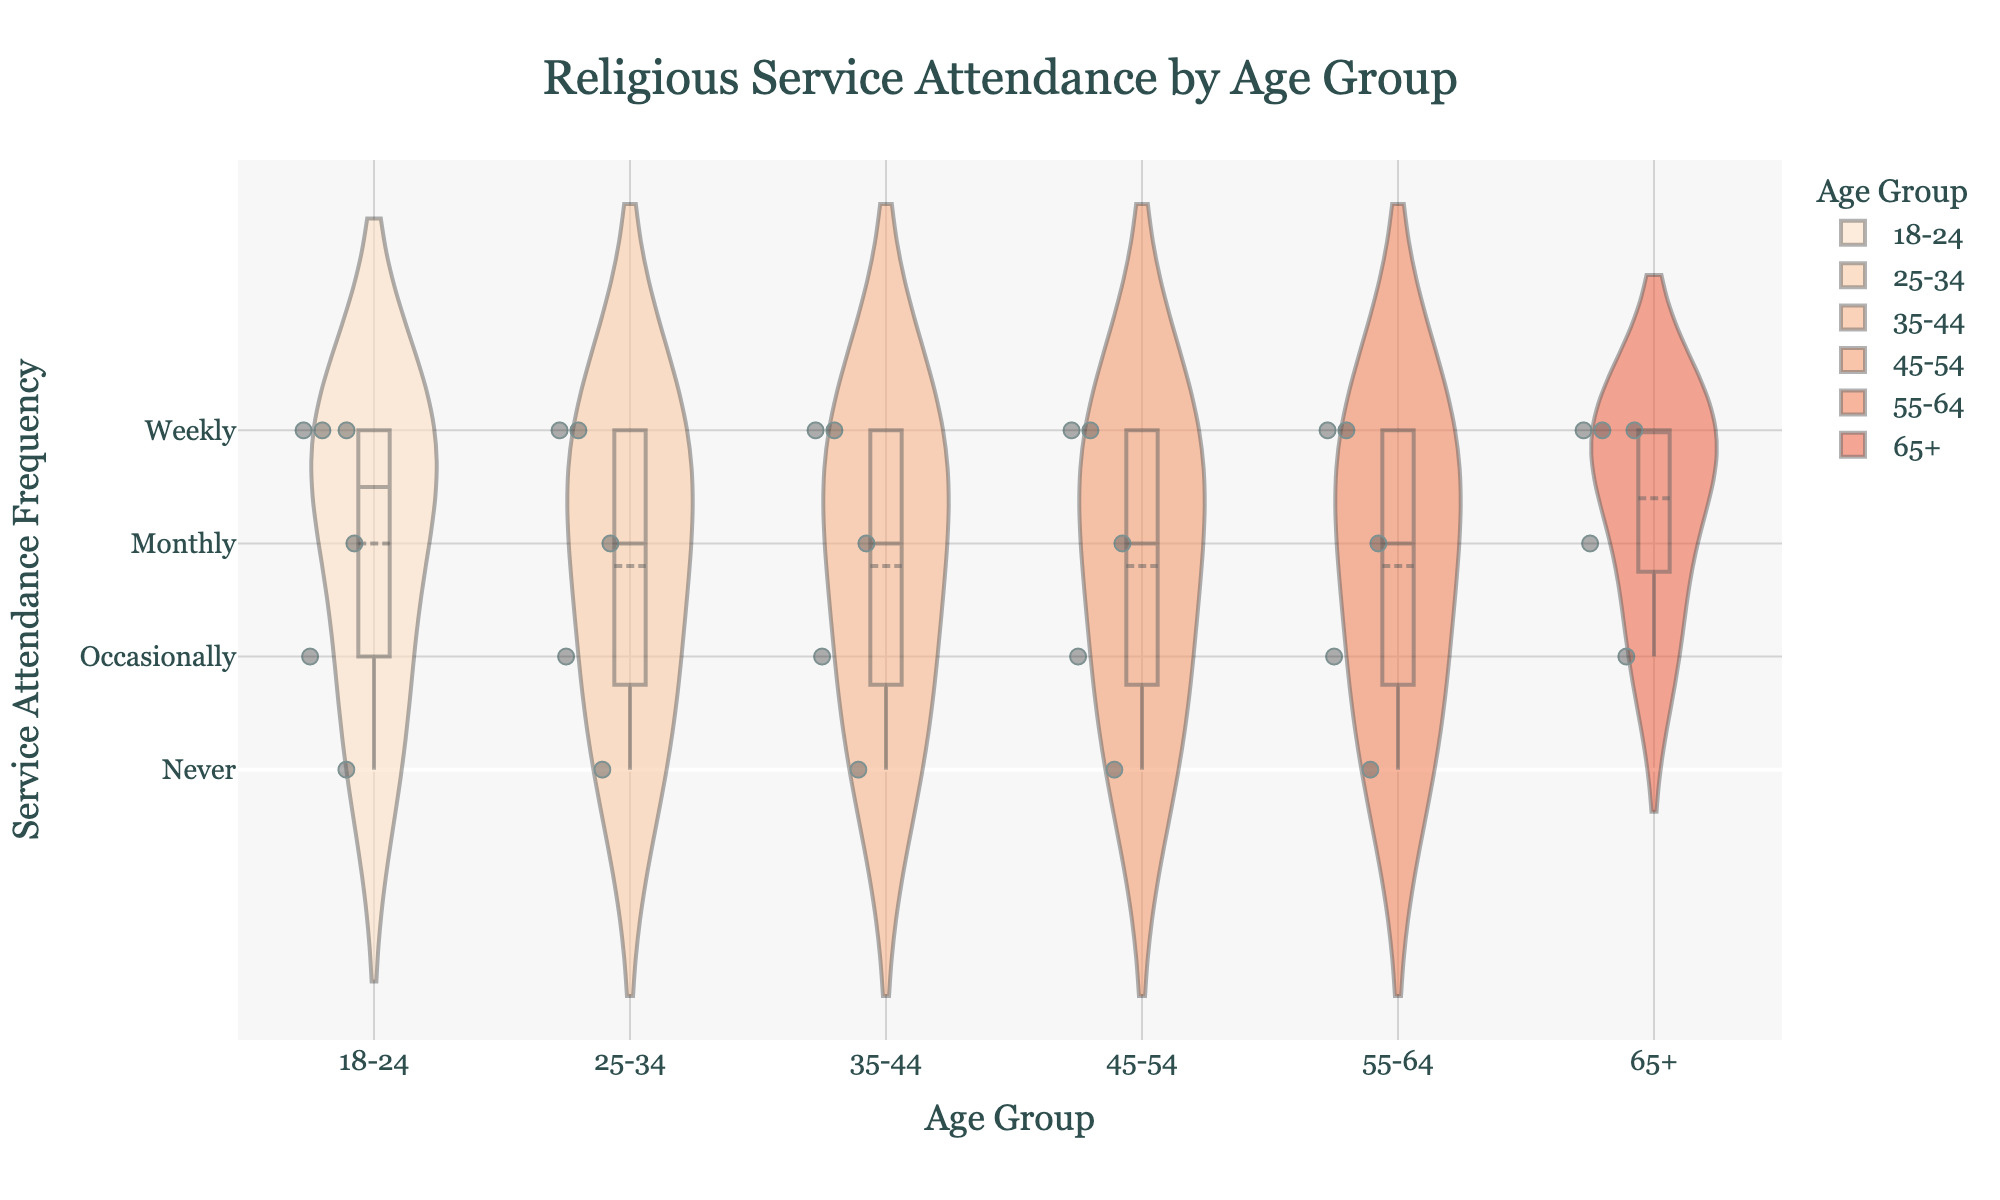what is the title of the figure? The title is located at the top center of the figure. It is usually larger and in bold. The title of this figure is "Religious Service Attendance by Age Group."
Answer: Religious Service Attendance by Age Group What age group has the most 'Weekly' attendees? Observe the peak and distribution of the 'Weekly' category for each age group. The age group with the highest density peak at 'Weekly' indicates the most attendees in that category.
Answer: 65+ How many points represent the 'Never' frequency in the 25-34 age group? 'Never' frequency is mapped to the value 0 on the y-axis. Count the jittered points at the y-value of 0 within the 25-34 age group section.
Answer: 1 Which age group shows the widest range in service attendance frequency? The range in a violin plot is from the minimum to the maximum value. Look for the age group with the longest vertical span from bottom to top.
Answer: 35-44 How does the average attendance frequency for the 18-24 age group compare to the 55-64 age group? Check the meanline positions in the violin plots for both age groups. Compare their average frequencies based on the meanline.
Answer: 55-64 has a higher average Among all age groups, which one has the least 'Occasionally' attendees? 'Occasionally' frequency corresponds to the value 1 on the y-axis. Compare the density and number of points at y=1 across all age groups.
Answer: 65+ Which age group has more variability in attendance frequency: 45-54 or 55-64? Variability is indicated by the width of the violin plot. Compare the spread of the plots between these two age groups.
Answer: 45-54 What is the median attendance frequency for the 35-44 age group? The median can be observed from the centerline in the box visible within the violin plot for the 35-44 age group.
Answer: Monthly 